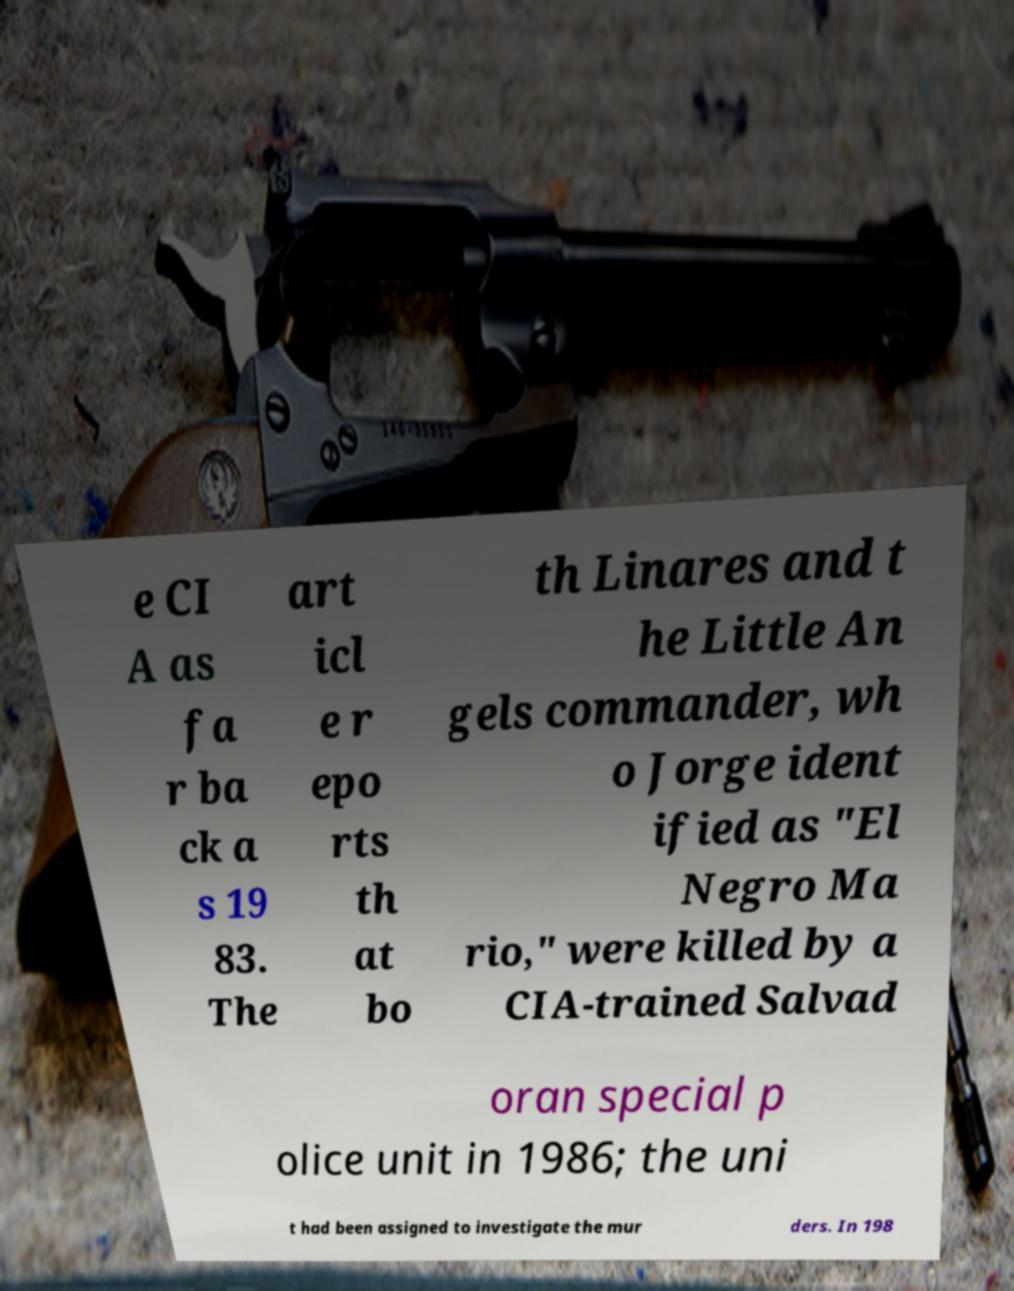Please identify and transcribe the text found in this image. e CI A as fa r ba ck a s 19 83. The art icl e r epo rts th at bo th Linares and t he Little An gels commander, wh o Jorge ident ified as "El Negro Ma rio," were killed by a CIA-trained Salvad oran special p olice unit in 1986; the uni t had been assigned to investigate the mur ders. In 198 